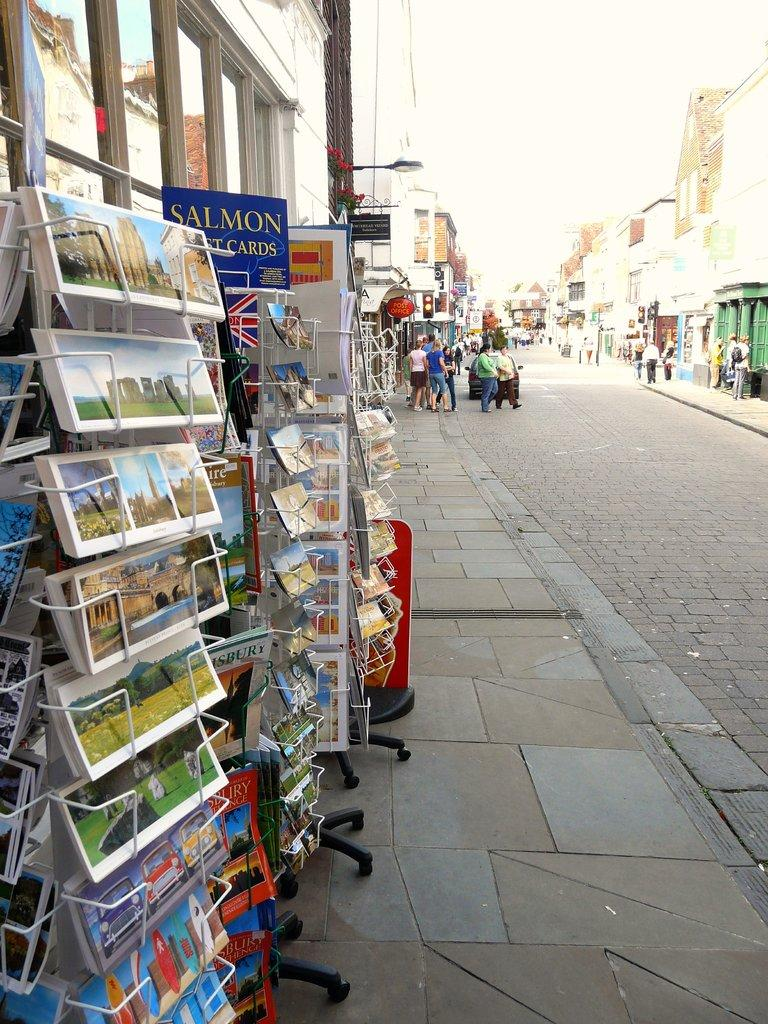Provide a one-sentence caption for the provided image. Racks of postcards, one rack labeled Salmon, sits on a sidewalk outside of a store. 